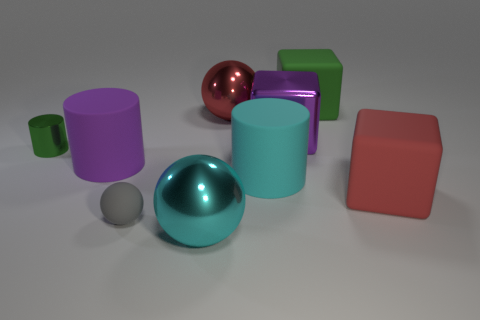Can you describe the texture and color of the cube closest to the center? The cube near the center has a smooth, rubberlike texture and is colored in a vibrant shade of green. Its surface reflects a soft glow, suggesting it's not highly shiny, but has a slight sheen to it. 